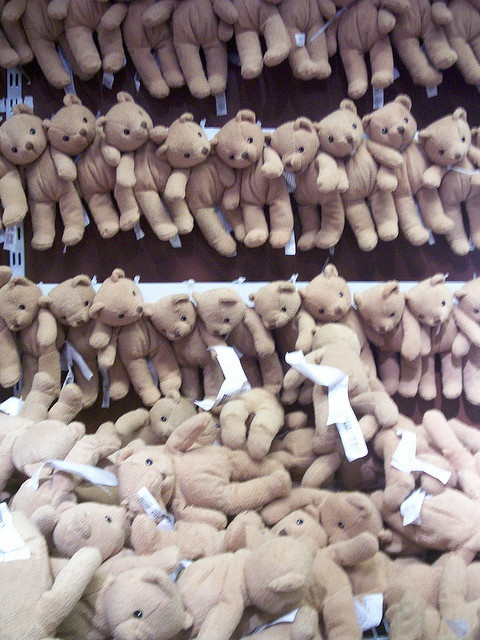Describe the objects in this image and their specific colors. I can see teddy bear in black, darkgray, lightgray, and gray tones, teddy bear in black, lightgray, tan, and darkgray tones, teddy bear in black, darkgray, brown, gray, and tan tones, teddy bear in black, darkgray, gray, and lightgray tones, and teddy bear in black, gray, darkgray, and tan tones in this image. 